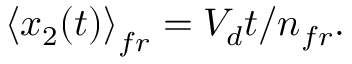Convert formula to latex. <formula><loc_0><loc_0><loc_500><loc_500>\left \langle x _ { 2 } ( t ) \right \rangle _ { f r } = V _ { d } t / n _ { f r } .</formula> 